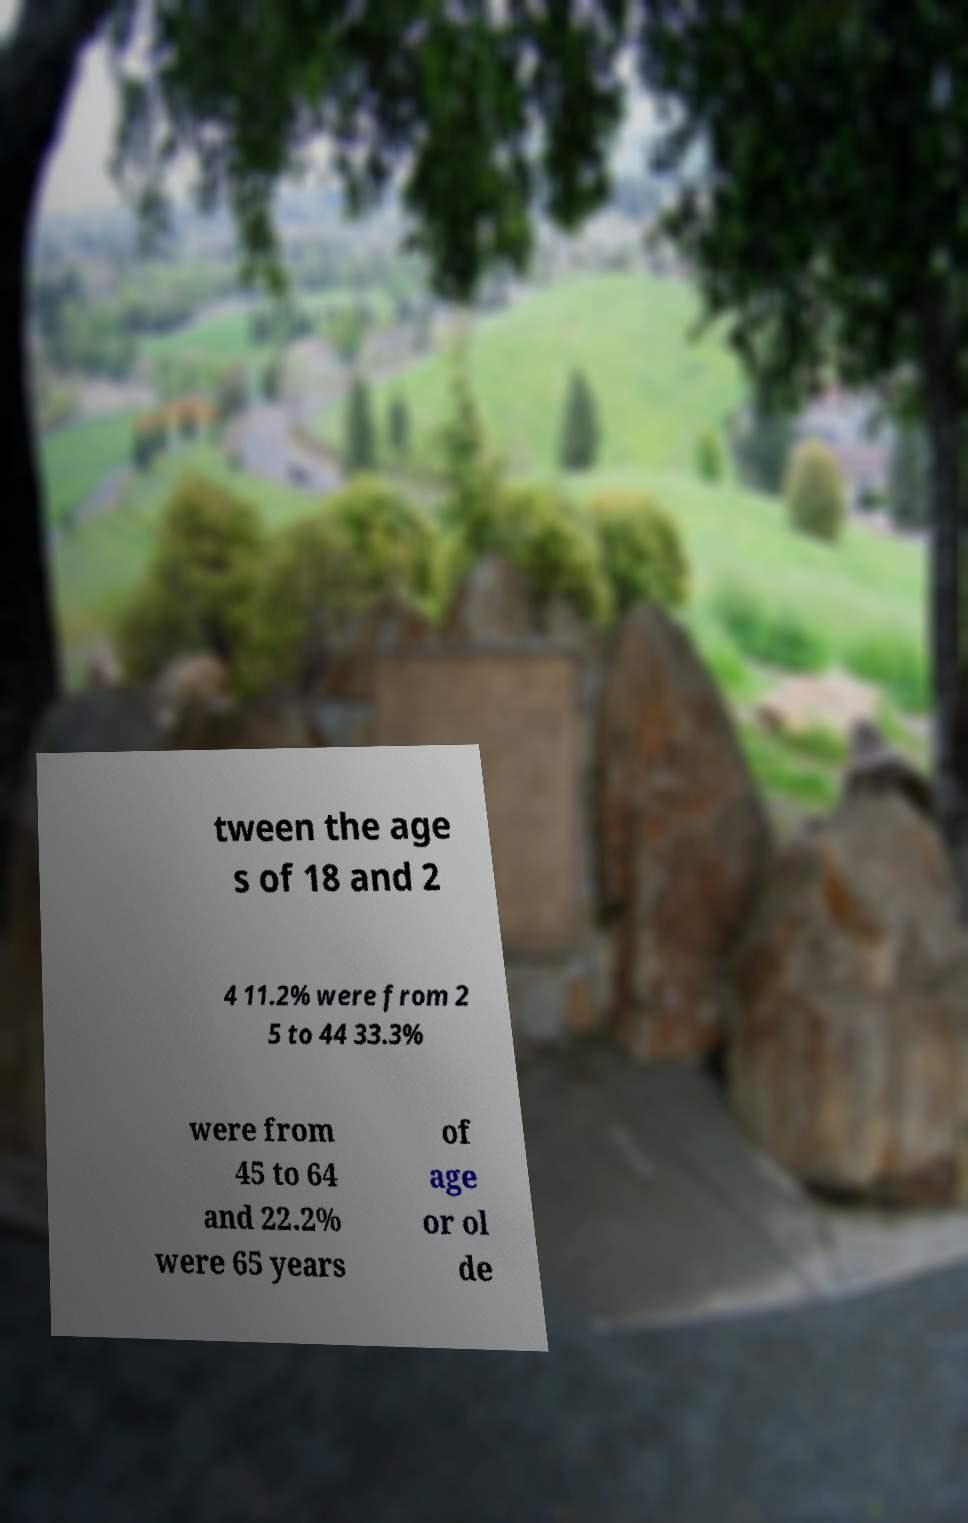There's text embedded in this image that I need extracted. Can you transcribe it verbatim? tween the age s of 18 and 2 4 11.2% were from 2 5 to 44 33.3% were from 45 to 64 and 22.2% were 65 years of age or ol de 